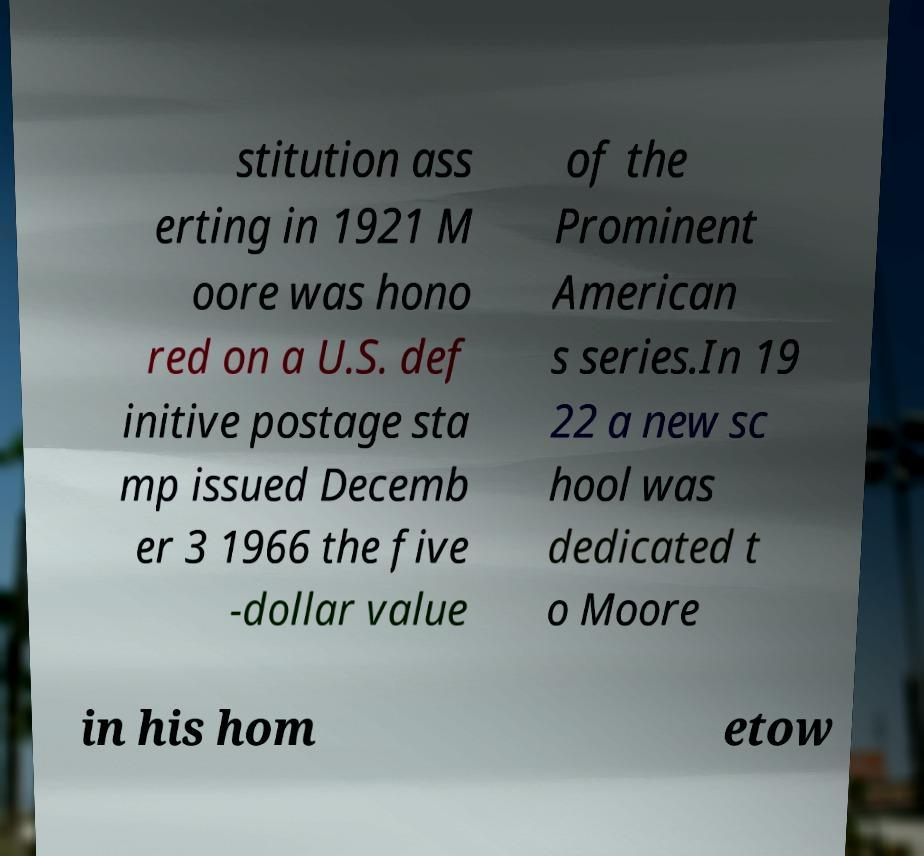What messages or text are displayed in this image? I need them in a readable, typed format. stitution ass erting in 1921 M oore was hono red on a U.S. def initive postage sta mp issued Decemb er 3 1966 the five -dollar value of the Prominent American s series.In 19 22 a new sc hool was dedicated t o Moore in his hom etow 